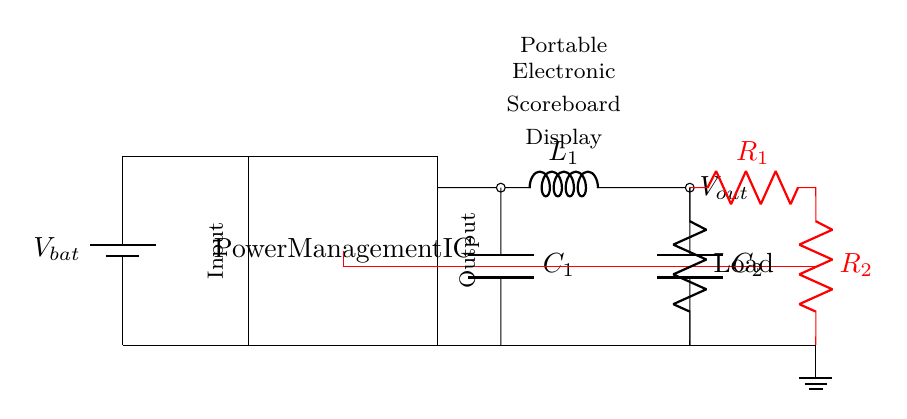What is the type of the load in this circuit? The load is identified as a resistor labeled "Load" connected to the output. This indicates that the load is a discrete resistive component.
Answer: Resistor What component regulates the output voltage? The Power Management IC functions as the voltage regulation component in this circuit. It controls the output voltage by utilizing the buck converter design, ensuring it remains stable.
Answer: Power Management IC How many capacitors are used in the circuit? Two capacitors are present, labeled C1 and C2. They are connected at the output side of the buck converter to smooth out voltage fluctuations.
Answer: Two What role does the inductor play in the circuit? The inductor labeled L1 is part of the buck converter and helps to store energy and smooth the output voltage. This function fits the typical role of inductors in switching regulators, where they assist in energy transfer during the operation cycle.
Answer: Energy storage What feedback components are used in the circuit? The feedback path uses two resistors labeled R1 and R2. They are connected together to form a voltage divider, which provides feedback to the Power Management IC for regulating the output voltage.
Answer: Resistors R1 and R2 